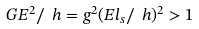<formula> <loc_0><loc_0><loc_500><loc_500>G E ^ { 2 } / \ h = g ^ { 2 } ( E l _ { s } / \ h ) ^ { 2 } > 1</formula> 